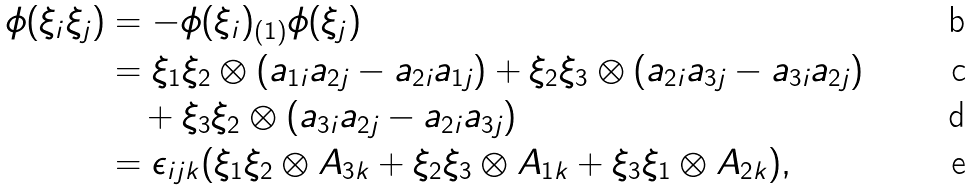<formula> <loc_0><loc_0><loc_500><loc_500>\phi ( \xi _ { i } \xi _ { j } ) & = - \phi ( \xi _ { i } ) _ { ( 1 ) } \phi ( \xi _ { j } ) \\ & = \xi _ { 1 } \xi _ { 2 } \otimes ( a _ { 1 i } a _ { 2 j } - a _ { 2 i } a _ { 1 j } ) + \xi _ { 2 } \xi _ { 3 } \otimes ( a _ { 2 i } a _ { 3 j } - a _ { 3 i } a _ { 2 j } ) \\ & \quad + \xi _ { 3 } \xi _ { 2 } \otimes ( a _ { 3 i } a _ { 2 j } - a _ { 2 i } a _ { 3 j } ) \\ & = \epsilon _ { i j k } ( \xi _ { 1 } \xi _ { 2 } \otimes A _ { 3 k } + \xi _ { 2 } \xi _ { 3 } \otimes A _ { 1 k } + \xi _ { 3 } \xi _ { 1 } \otimes A _ { 2 k } ) ,</formula> 